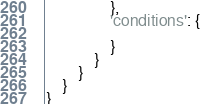<code> <loc_0><loc_0><loc_500><loc_500><_Python_>                },
                'conditions': {

                }
            }
        }
    }
}
</code> 